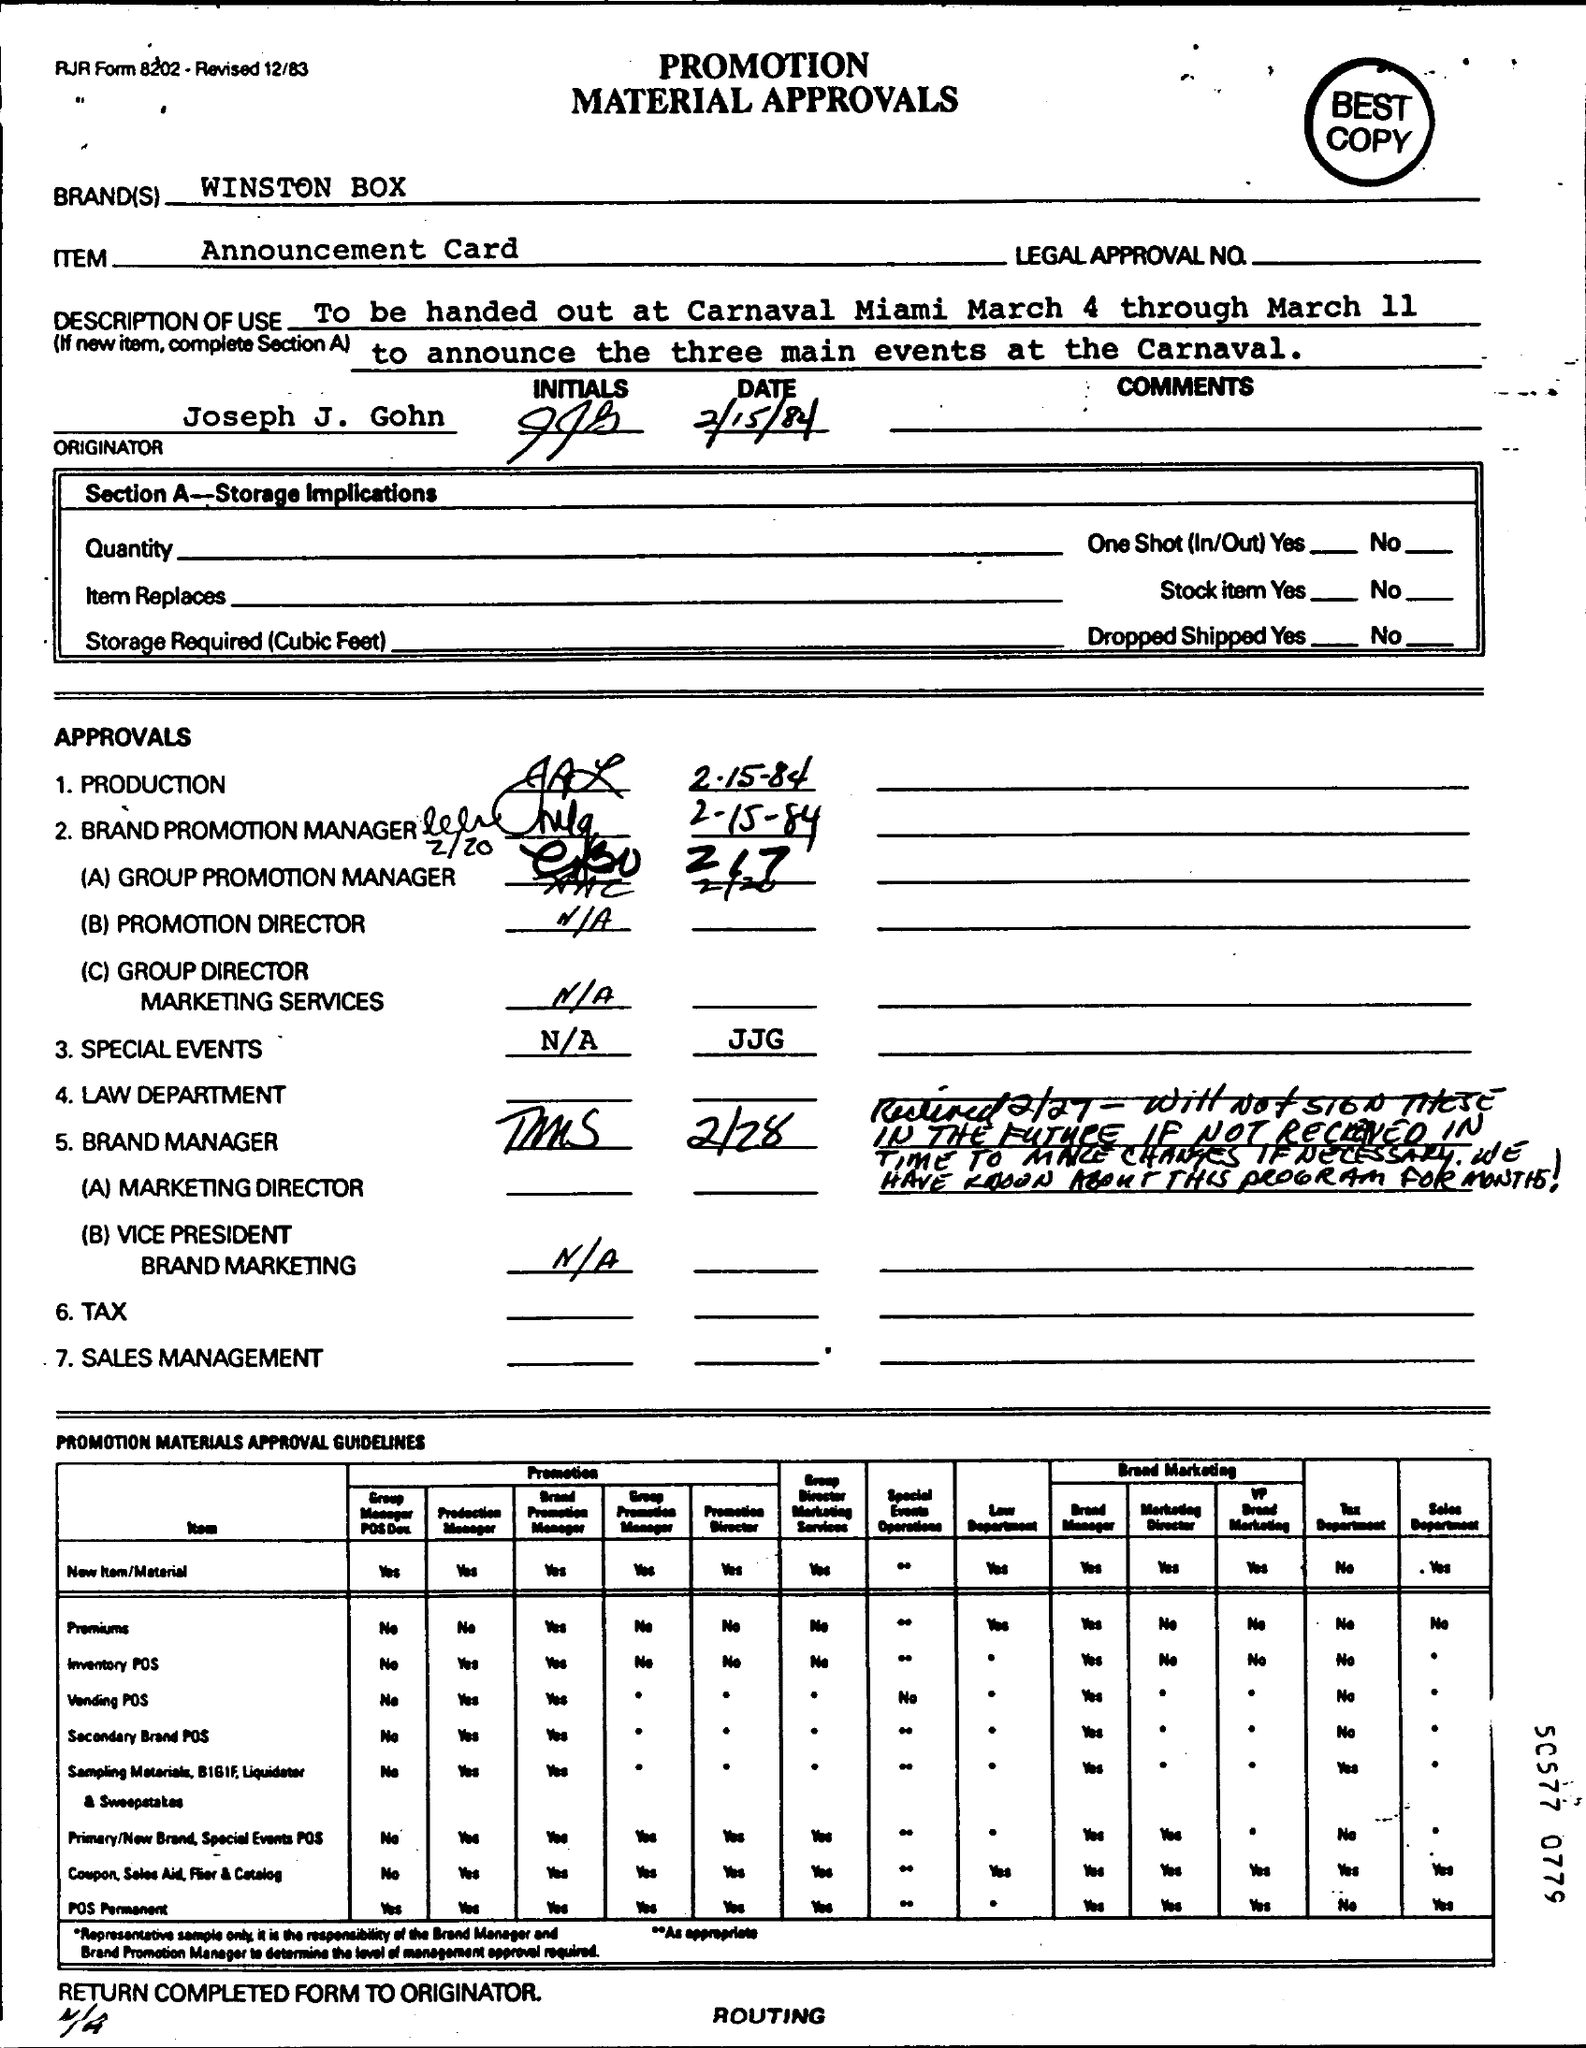Indicate a few pertinent items in this graphic. The item in question is an Announcement Card. WINSTON BOX is the brand that is being referred to. The person who is the originator is Joseph J. Gohn. 